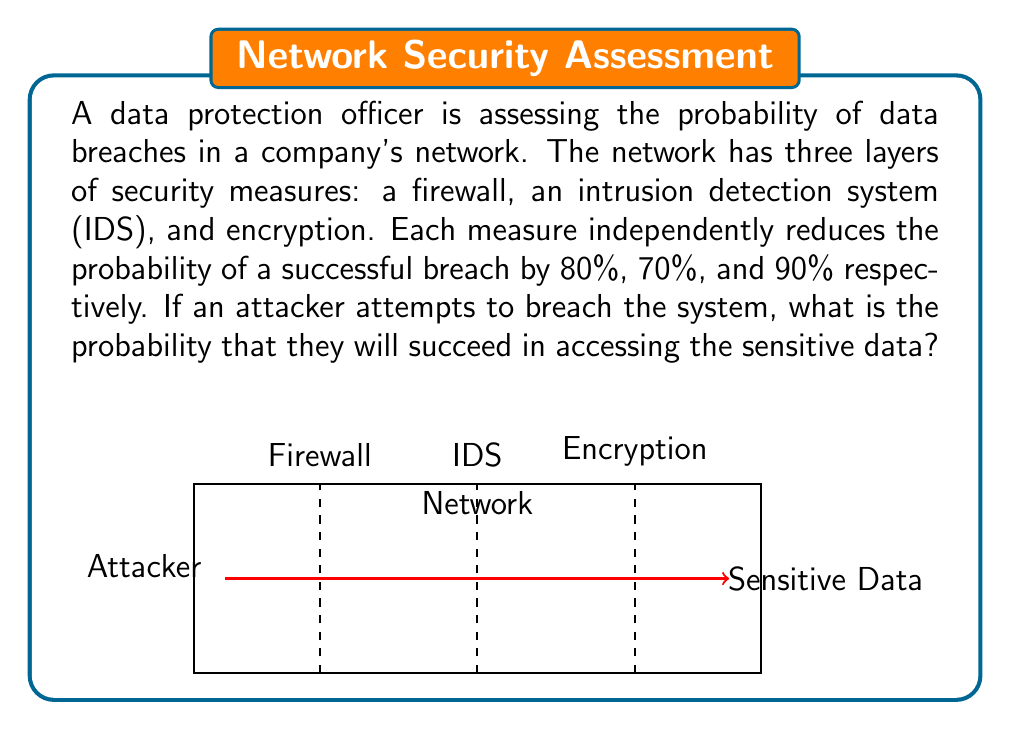Help me with this question. To solve this problem, we need to calculate the probability of a successful breach given that there are three independent security measures. Let's approach this step-by-step:

1) First, let's define the probability of bypassing each security measure:
   - Firewall: 20% (100% - 80% reduction)
   - IDS: 30% (100% - 70% reduction)
   - Encryption: 10% (100% - 90% reduction)

2) For a successful breach, the attacker needs to bypass all three measures. Since these are independent events, we multiply the probabilities:

   $$P(\text{successful breach}) = P(\text{bypass firewall}) \times P(\text{bypass IDS}) \times P(\text{bypass encryption})$$

3) Substituting the values:

   $$P(\text{successful breach}) = 0.20 \times 0.30 \times 0.10$$

4) Calculate:

   $$P(\text{successful breach}) = 0.006$$

5) Convert to percentage:

   $$P(\text{successful breach}) = 0.006 \times 100\% = 0.6\%$$

Therefore, the probability that an attacker will succeed in accessing the sensitive data is 0.6%.
Answer: 0.6% 